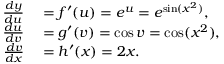Convert formula to latex. <formula><loc_0><loc_0><loc_500><loc_500>\begin{array} { r l } { { \frac { d y } { d u } } } & = f ^ { \prime } ( u ) = e ^ { u } = e ^ { \sin ( x ^ { 2 } ) } , } \\ { { \frac { d u } { d v } } } & = g ^ { \prime } ( v ) = \cos v = \cos ( x ^ { 2 } ) , } \\ { { \frac { d v } { d x } } } & = h ^ { \prime } ( x ) = 2 x . } \end{array}</formula> 